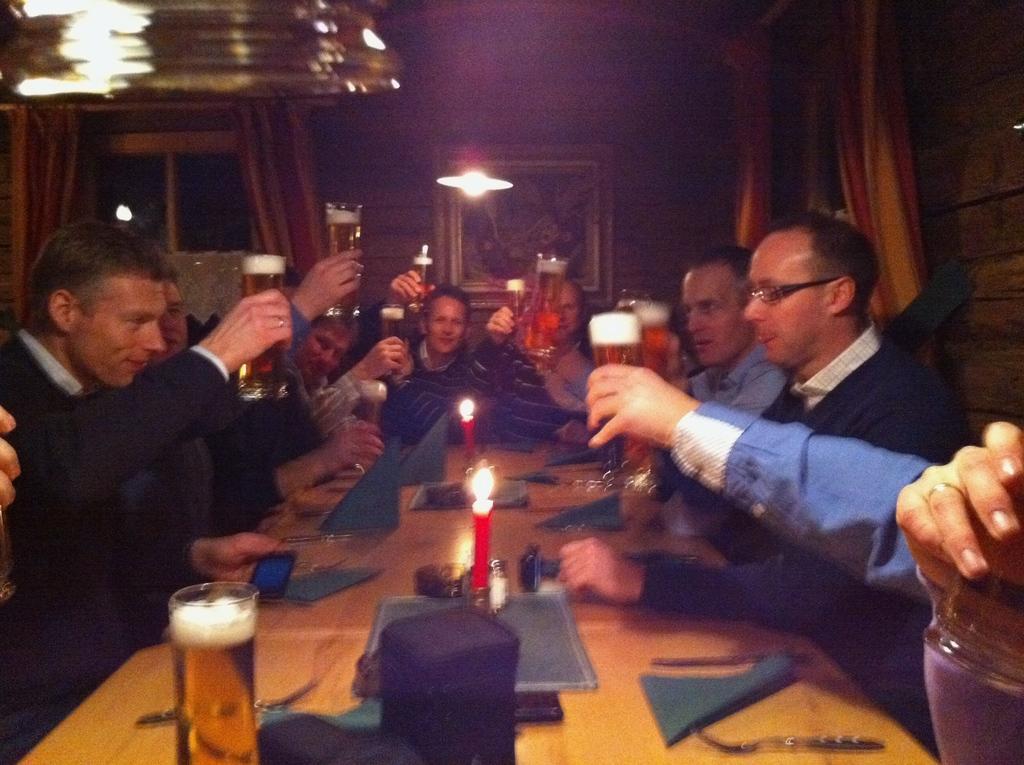Describe this image in one or two sentences. In this image there are group of people sitting on the chair. On the table there is a glass,candle ,cloth and a spoon. At the background we can see a curtain and frame attached to the wall. The person is holding a glass. 